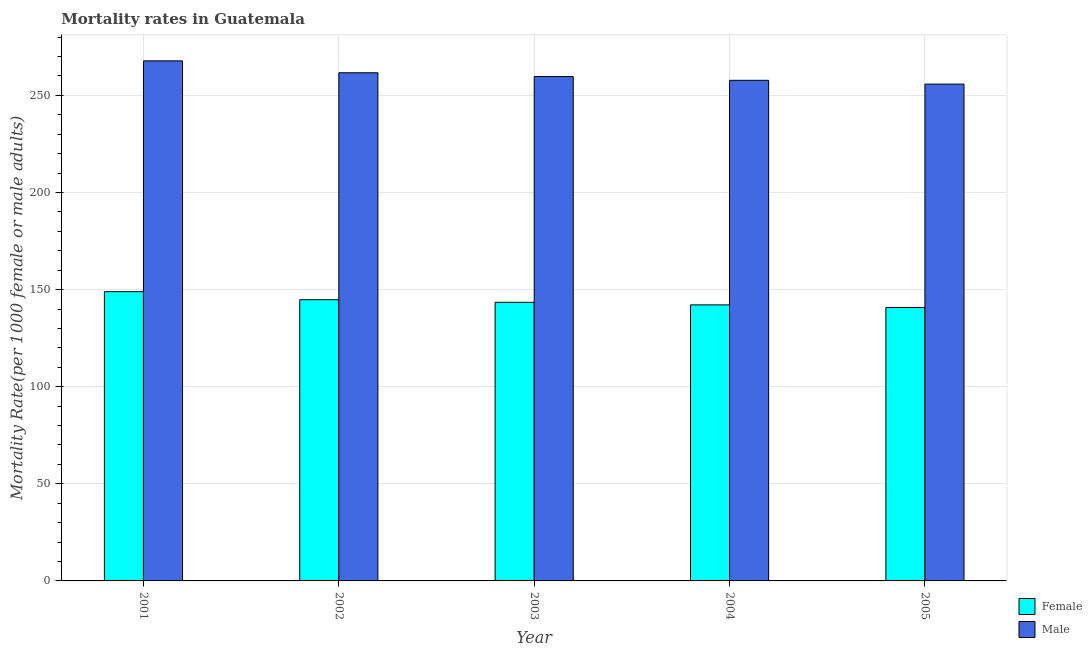How many different coloured bars are there?
Keep it short and to the point. 2. Are the number of bars per tick equal to the number of legend labels?
Your answer should be very brief. Yes. Are the number of bars on each tick of the X-axis equal?
Your answer should be very brief. Yes. How many bars are there on the 3rd tick from the left?
Provide a short and direct response. 2. How many bars are there on the 1st tick from the right?
Keep it short and to the point. 2. In how many cases, is the number of bars for a given year not equal to the number of legend labels?
Make the answer very short. 0. What is the female mortality rate in 2001?
Ensure brevity in your answer.  148.92. Across all years, what is the maximum male mortality rate?
Ensure brevity in your answer.  267.75. Across all years, what is the minimum male mortality rate?
Make the answer very short. 255.79. In which year was the male mortality rate maximum?
Keep it short and to the point. 2001. What is the total male mortality rate in the graph?
Make the answer very short. 1302.59. What is the difference between the female mortality rate in 2003 and that in 2005?
Ensure brevity in your answer.  2.66. What is the difference between the female mortality rate in 2005 and the male mortality rate in 2004?
Your response must be concise. -1.33. What is the average female mortality rate per year?
Offer a very short reply. 144.01. What is the ratio of the male mortality rate in 2004 to that in 2005?
Your answer should be very brief. 1.01. Is the difference between the male mortality rate in 2003 and 2005 greater than the difference between the female mortality rate in 2003 and 2005?
Offer a terse response. No. What is the difference between the highest and the second highest female mortality rate?
Offer a very short reply. 4.13. What is the difference between the highest and the lowest male mortality rate?
Keep it short and to the point. 11.96. Is the sum of the male mortality rate in 2001 and 2004 greater than the maximum female mortality rate across all years?
Your answer should be compact. Yes. How many bars are there?
Make the answer very short. 10. Are the values on the major ticks of Y-axis written in scientific E-notation?
Offer a terse response. No. Does the graph contain any zero values?
Keep it short and to the point. No. Where does the legend appear in the graph?
Make the answer very short. Bottom right. How are the legend labels stacked?
Give a very brief answer. Vertical. What is the title of the graph?
Ensure brevity in your answer.  Mortality rates in Guatemala. Does "Under-5(female)" appear as one of the legend labels in the graph?
Make the answer very short. No. What is the label or title of the Y-axis?
Your response must be concise. Mortality Rate(per 1000 female or male adults). What is the Mortality Rate(per 1000 female or male adults) in Female in 2001?
Provide a succinct answer. 148.92. What is the Mortality Rate(per 1000 female or male adults) in Male in 2001?
Ensure brevity in your answer.  267.75. What is the Mortality Rate(per 1000 female or male adults) of Female in 2002?
Provide a succinct answer. 144.78. What is the Mortality Rate(per 1000 female or male adults) of Male in 2002?
Your answer should be compact. 261.63. What is the Mortality Rate(per 1000 female or male adults) in Female in 2003?
Make the answer very short. 143.45. What is the Mortality Rate(per 1000 female or male adults) of Male in 2003?
Give a very brief answer. 259.68. What is the Mortality Rate(per 1000 female or male adults) in Female in 2004?
Give a very brief answer. 142.12. What is the Mortality Rate(per 1000 female or male adults) in Male in 2004?
Ensure brevity in your answer.  257.74. What is the Mortality Rate(per 1000 female or male adults) of Female in 2005?
Your answer should be compact. 140.79. What is the Mortality Rate(per 1000 female or male adults) of Male in 2005?
Make the answer very short. 255.79. Across all years, what is the maximum Mortality Rate(per 1000 female or male adults) of Female?
Make the answer very short. 148.92. Across all years, what is the maximum Mortality Rate(per 1000 female or male adults) in Male?
Offer a terse response. 267.75. Across all years, what is the minimum Mortality Rate(per 1000 female or male adults) of Female?
Keep it short and to the point. 140.79. Across all years, what is the minimum Mortality Rate(per 1000 female or male adults) in Male?
Make the answer very short. 255.79. What is the total Mortality Rate(per 1000 female or male adults) of Female in the graph?
Ensure brevity in your answer.  720.07. What is the total Mortality Rate(per 1000 female or male adults) of Male in the graph?
Your answer should be compact. 1302.59. What is the difference between the Mortality Rate(per 1000 female or male adults) in Female in 2001 and that in 2002?
Offer a very short reply. 4.13. What is the difference between the Mortality Rate(per 1000 female or male adults) in Male in 2001 and that in 2002?
Ensure brevity in your answer.  6.12. What is the difference between the Mortality Rate(per 1000 female or male adults) in Female in 2001 and that in 2003?
Give a very brief answer. 5.46. What is the difference between the Mortality Rate(per 1000 female or male adults) in Male in 2001 and that in 2003?
Give a very brief answer. 8.06. What is the difference between the Mortality Rate(per 1000 female or male adults) in Female in 2001 and that in 2004?
Your answer should be very brief. 6.79. What is the difference between the Mortality Rate(per 1000 female or male adults) in Male in 2001 and that in 2004?
Provide a succinct answer. 10.01. What is the difference between the Mortality Rate(per 1000 female or male adults) in Female in 2001 and that in 2005?
Give a very brief answer. 8.13. What is the difference between the Mortality Rate(per 1000 female or male adults) of Male in 2001 and that in 2005?
Provide a succinct answer. 11.96. What is the difference between the Mortality Rate(per 1000 female or male adults) of Female in 2002 and that in 2003?
Keep it short and to the point. 1.33. What is the difference between the Mortality Rate(per 1000 female or male adults) in Male in 2002 and that in 2003?
Ensure brevity in your answer.  1.95. What is the difference between the Mortality Rate(per 1000 female or male adults) of Female in 2002 and that in 2004?
Provide a succinct answer. 2.66. What is the difference between the Mortality Rate(per 1000 female or male adults) of Male in 2002 and that in 2004?
Offer a terse response. 3.9. What is the difference between the Mortality Rate(per 1000 female or male adults) of Female in 2002 and that in 2005?
Your response must be concise. 3.99. What is the difference between the Mortality Rate(per 1000 female or male adults) in Male in 2002 and that in 2005?
Offer a very short reply. 5.85. What is the difference between the Mortality Rate(per 1000 female or male adults) of Female in 2003 and that in 2004?
Keep it short and to the point. 1.33. What is the difference between the Mortality Rate(per 1000 female or male adults) of Male in 2003 and that in 2004?
Your answer should be compact. 1.95. What is the difference between the Mortality Rate(per 1000 female or male adults) in Female in 2003 and that in 2005?
Your answer should be compact. 2.66. What is the difference between the Mortality Rate(per 1000 female or male adults) of Male in 2003 and that in 2005?
Offer a very short reply. 3.9. What is the difference between the Mortality Rate(per 1000 female or male adults) of Female in 2004 and that in 2005?
Keep it short and to the point. 1.33. What is the difference between the Mortality Rate(per 1000 female or male adults) in Male in 2004 and that in 2005?
Your answer should be compact. 1.95. What is the difference between the Mortality Rate(per 1000 female or male adults) in Female in 2001 and the Mortality Rate(per 1000 female or male adults) in Male in 2002?
Give a very brief answer. -112.72. What is the difference between the Mortality Rate(per 1000 female or male adults) in Female in 2001 and the Mortality Rate(per 1000 female or male adults) in Male in 2003?
Give a very brief answer. -110.77. What is the difference between the Mortality Rate(per 1000 female or male adults) in Female in 2001 and the Mortality Rate(per 1000 female or male adults) in Male in 2004?
Provide a succinct answer. -108.82. What is the difference between the Mortality Rate(per 1000 female or male adults) of Female in 2001 and the Mortality Rate(per 1000 female or male adults) of Male in 2005?
Offer a very short reply. -106.87. What is the difference between the Mortality Rate(per 1000 female or male adults) of Female in 2002 and the Mortality Rate(per 1000 female or male adults) of Male in 2003?
Make the answer very short. -114.9. What is the difference between the Mortality Rate(per 1000 female or male adults) of Female in 2002 and the Mortality Rate(per 1000 female or male adults) of Male in 2004?
Make the answer very short. -112.95. What is the difference between the Mortality Rate(per 1000 female or male adults) of Female in 2002 and the Mortality Rate(per 1000 female or male adults) of Male in 2005?
Offer a very short reply. -111. What is the difference between the Mortality Rate(per 1000 female or male adults) in Female in 2003 and the Mortality Rate(per 1000 female or male adults) in Male in 2004?
Offer a very short reply. -114.28. What is the difference between the Mortality Rate(per 1000 female or male adults) of Female in 2003 and the Mortality Rate(per 1000 female or male adults) of Male in 2005?
Keep it short and to the point. -112.33. What is the difference between the Mortality Rate(per 1000 female or male adults) in Female in 2004 and the Mortality Rate(per 1000 female or male adults) in Male in 2005?
Give a very brief answer. -113.66. What is the average Mortality Rate(per 1000 female or male adults) in Female per year?
Provide a succinct answer. 144.01. What is the average Mortality Rate(per 1000 female or male adults) in Male per year?
Your answer should be compact. 260.52. In the year 2001, what is the difference between the Mortality Rate(per 1000 female or male adults) of Female and Mortality Rate(per 1000 female or male adults) of Male?
Offer a very short reply. -118.83. In the year 2002, what is the difference between the Mortality Rate(per 1000 female or male adults) in Female and Mortality Rate(per 1000 female or male adults) in Male?
Provide a short and direct response. -116.85. In the year 2003, what is the difference between the Mortality Rate(per 1000 female or male adults) in Female and Mortality Rate(per 1000 female or male adults) in Male?
Offer a terse response. -116.23. In the year 2004, what is the difference between the Mortality Rate(per 1000 female or male adults) in Female and Mortality Rate(per 1000 female or male adults) in Male?
Your response must be concise. -115.61. In the year 2005, what is the difference between the Mortality Rate(per 1000 female or male adults) of Female and Mortality Rate(per 1000 female or male adults) of Male?
Give a very brief answer. -115. What is the ratio of the Mortality Rate(per 1000 female or male adults) in Female in 2001 to that in 2002?
Your answer should be compact. 1.03. What is the ratio of the Mortality Rate(per 1000 female or male adults) of Male in 2001 to that in 2002?
Offer a terse response. 1.02. What is the ratio of the Mortality Rate(per 1000 female or male adults) in Female in 2001 to that in 2003?
Your answer should be compact. 1.04. What is the ratio of the Mortality Rate(per 1000 female or male adults) in Male in 2001 to that in 2003?
Your answer should be compact. 1.03. What is the ratio of the Mortality Rate(per 1000 female or male adults) of Female in 2001 to that in 2004?
Offer a very short reply. 1.05. What is the ratio of the Mortality Rate(per 1000 female or male adults) in Male in 2001 to that in 2004?
Provide a short and direct response. 1.04. What is the ratio of the Mortality Rate(per 1000 female or male adults) in Female in 2001 to that in 2005?
Give a very brief answer. 1.06. What is the ratio of the Mortality Rate(per 1000 female or male adults) in Male in 2001 to that in 2005?
Offer a very short reply. 1.05. What is the ratio of the Mortality Rate(per 1000 female or male adults) in Female in 2002 to that in 2003?
Provide a short and direct response. 1.01. What is the ratio of the Mortality Rate(per 1000 female or male adults) in Male in 2002 to that in 2003?
Your answer should be compact. 1.01. What is the ratio of the Mortality Rate(per 1000 female or male adults) in Female in 2002 to that in 2004?
Ensure brevity in your answer.  1.02. What is the ratio of the Mortality Rate(per 1000 female or male adults) in Male in 2002 to that in 2004?
Your response must be concise. 1.02. What is the ratio of the Mortality Rate(per 1000 female or male adults) in Female in 2002 to that in 2005?
Your answer should be compact. 1.03. What is the ratio of the Mortality Rate(per 1000 female or male adults) of Male in 2002 to that in 2005?
Your answer should be very brief. 1.02. What is the ratio of the Mortality Rate(per 1000 female or male adults) in Female in 2003 to that in 2004?
Provide a short and direct response. 1.01. What is the ratio of the Mortality Rate(per 1000 female or male adults) in Male in 2003 to that in 2004?
Give a very brief answer. 1.01. What is the ratio of the Mortality Rate(per 1000 female or male adults) in Female in 2003 to that in 2005?
Your response must be concise. 1.02. What is the ratio of the Mortality Rate(per 1000 female or male adults) in Male in 2003 to that in 2005?
Provide a short and direct response. 1.02. What is the ratio of the Mortality Rate(per 1000 female or male adults) of Female in 2004 to that in 2005?
Provide a short and direct response. 1.01. What is the ratio of the Mortality Rate(per 1000 female or male adults) of Male in 2004 to that in 2005?
Provide a succinct answer. 1.01. What is the difference between the highest and the second highest Mortality Rate(per 1000 female or male adults) in Female?
Offer a terse response. 4.13. What is the difference between the highest and the second highest Mortality Rate(per 1000 female or male adults) of Male?
Your answer should be very brief. 6.12. What is the difference between the highest and the lowest Mortality Rate(per 1000 female or male adults) of Female?
Keep it short and to the point. 8.13. What is the difference between the highest and the lowest Mortality Rate(per 1000 female or male adults) of Male?
Your answer should be very brief. 11.96. 